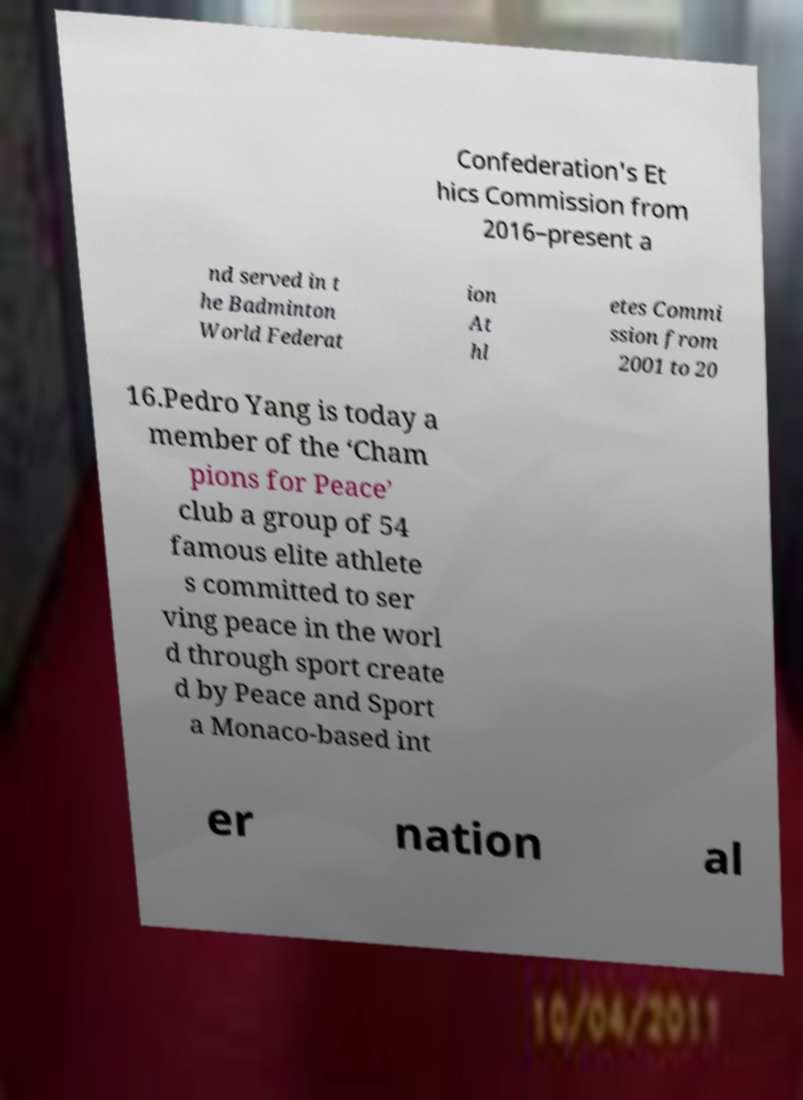There's text embedded in this image that I need extracted. Can you transcribe it verbatim? Confederation's Et hics Commission from 2016–present a nd served in t he Badminton World Federat ion At hl etes Commi ssion from 2001 to 20 16.Pedro Yang is today a member of the ‘Cham pions for Peace’ club a group of 54 famous elite athlete s committed to ser ving peace in the worl d through sport create d by Peace and Sport a Monaco-based int er nation al 